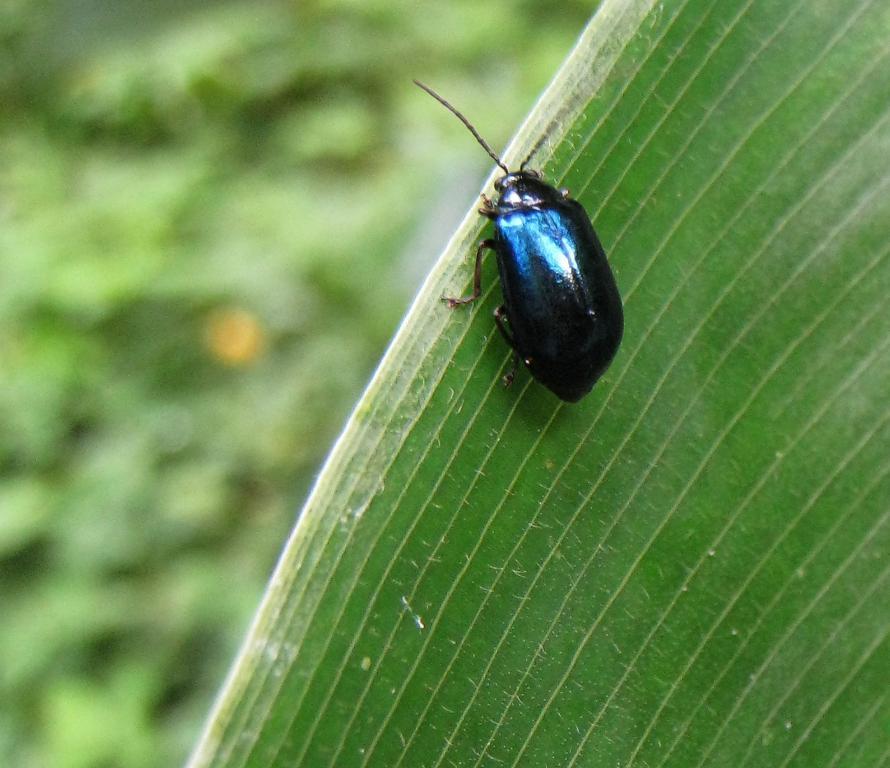Could you give a brief overview of what you see in this image? In the center of the image we can see a bug on the leaf. 